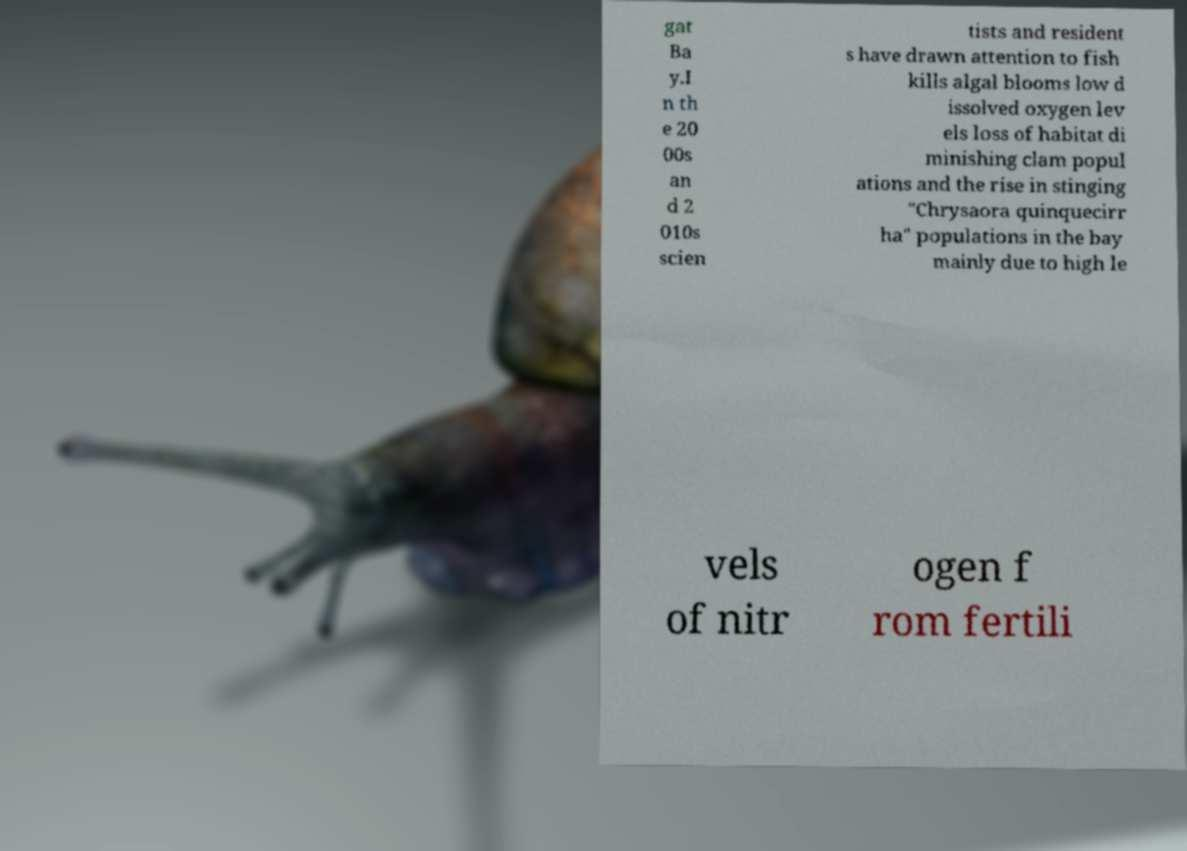What messages or text are displayed in this image? I need them in a readable, typed format. gat Ba y.I n th e 20 00s an d 2 010s scien tists and resident s have drawn attention to fish kills algal blooms low d issolved oxygen lev els loss of habitat di minishing clam popul ations and the rise in stinging "Chrysaora quinquecirr ha" populations in the bay mainly due to high le vels of nitr ogen f rom fertili 